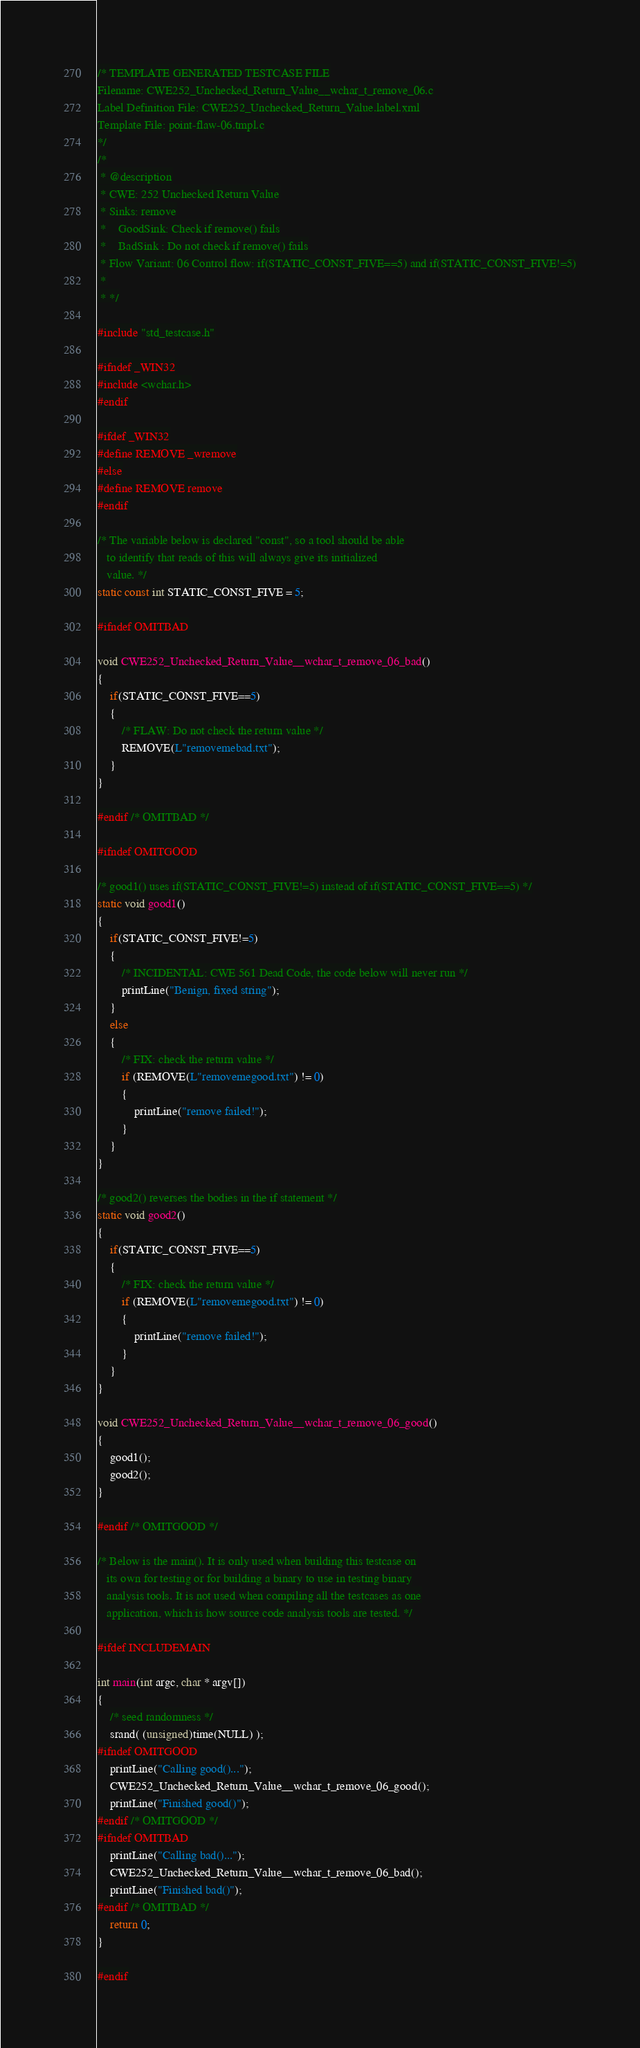Convert code to text. <code><loc_0><loc_0><loc_500><loc_500><_C_>/* TEMPLATE GENERATED TESTCASE FILE
Filename: CWE252_Unchecked_Return_Value__wchar_t_remove_06.c
Label Definition File: CWE252_Unchecked_Return_Value.label.xml
Template File: point-flaw-06.tmpl.c
*/
/*
 * @description
 * CWE: 252 Unchecked Return Value
 * Sinks: remove
 *    GoodSink: Check if remove() fails
 *    BadSink : Do not check if remove() fails
 * Flow Variant: 06 Control flow: if(STATIC_CONST_FIVE==5) and if(STATIC_CONST_FIVE!=5)
 *
 * */

#include "std_testcase.h"

#ifndef _WIN32
#include <wchar.h>
#endif

#ifdef _WIN32
#define REMOVE _wremove
#else
#define REMOVE remove
#endif

/* The variable below is declared "const", so a tool should be able
   to identify that reads of this will always give its initialized
   value. */
static const int STATIC_CONST_FIVE = 5;

#ifndef OMITBAD

void CWE252_Unchecked_Return_Value__wchar_t_remove_06_bad()
{
    if(STATIC_CONST_FIVE==5)
    {
        /* FLAW: Do not check the return value */
        REMOVE(L"removemebad.txt");
    }
}

#endif /* OMITBAD */

#ifndef OMITGOOD

/* good1() uses if(STATIC_CONST_FIVE!=5) instead of if(STATIC_CONST_FIVE==5) */
static void good1()
{
    if(STATIC_CONST_FIVE!=5)
    {
        /* INCIDENTAL: CWE 561 Dead Code, the code below will never run */
        printLine("Benign, fixed string");
    }
    else
    {
        /* FIX: check the return value */
        if (REMOVE(L"removemegood.txt") != 0)
        {
            printLine("remove failed!");
        }
    }
}

/* good2() reverses the bodies in the if statement */
static void good2()
{
    if(STATIC_CONST_FIVE==5)
    {
        /* FIX: check the return value */
        if (REMOVE(L"removemegood.txt") != 0)
        {
            printLine("remove failed!");
        }
    }
}

void CWE252_Unchecked_Return_Value__wchar_t_remove_06_good()
{
    good1();
    good2();
}

#endif /* OMITGOOD */

/* Below is the main(). It is only used when building this testcase on
   its own for testing or for building a binary to use in testing binary
   analysis tools. It is not used when compiling all the testcases as one
   application, which is how source code analysis tools are tested. */

#ifdef INCLUDEMAIN

int main(int argc, char * argv[])
{
    /* seed randomness */
    srand( (unsigned)time(NULL) );
#ifndef OMITGOOD
    printLine("Calling good()...");
    CWE252_Unchecked_Return_Value__wchar_t_remove_06_good();
    printLine("Finished good()");
#endif /* OMITGOOD */
#ifndef OMITBAD
    printLine("Calling bad()...");
    CWE252_Unchecked_Return_Value__wchar_t_remove_06_bad();
    printLine("Finished bad()");
#endif /* OMITBAD */
    return 0;
}

#endif
</code> 